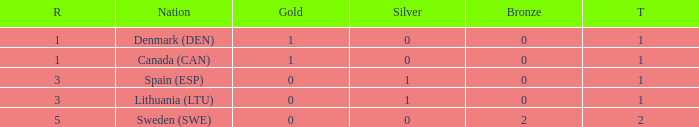What is the rank when there is 0 gold, the total is more than 1, and silver is more than 0? None. Can you parse all the data within this table? {'header': ['R', 'Nation', 'Gold', 'Silver', 'Bronze', 'T'], 'rows': [['1', 'Denmark (DEN)', '1', '0', '0', '1'], ['1', 'Canada (CAN)', '1', '0', '0', '1'], ['3', 'Spain (ESP)', '0', '1', '0', '1'], ['3', 'Lithuania (LTU)', '0', '1', '0', '1'], ['5', 'Sweden (SWE)', '0', '0', '2', '2']]} 